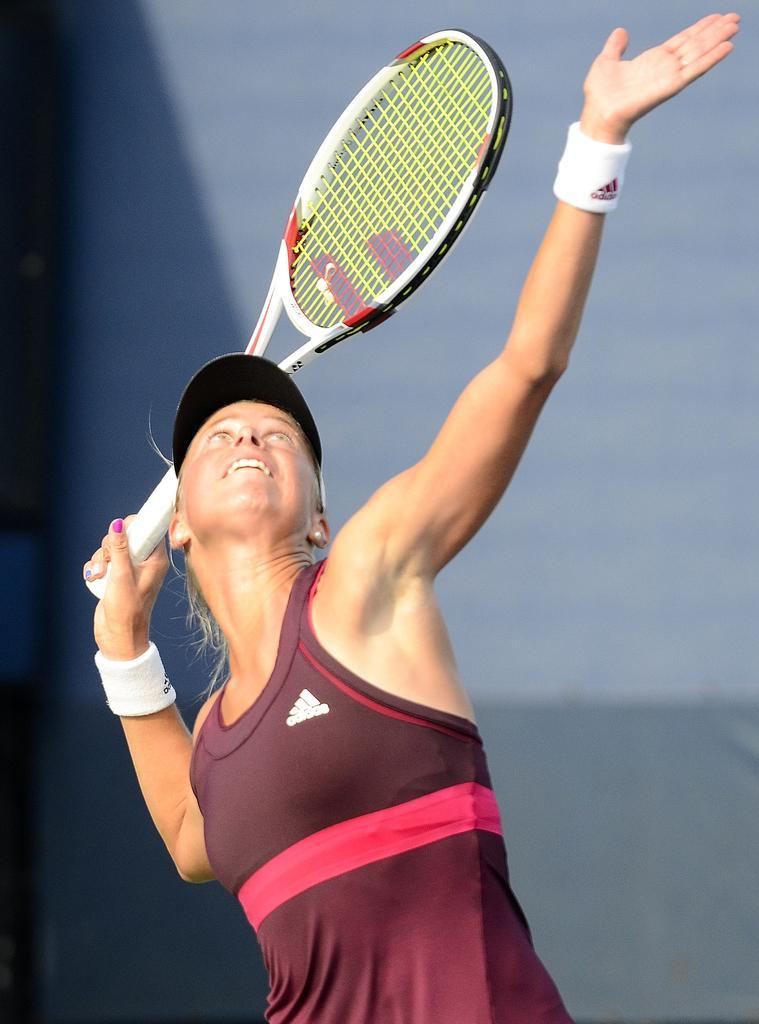In one or two sentences, can you explain what this image depicts? In the middle of the image a woman is standing and holding a tennis racket. Behind her there is wall. 